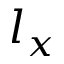<formula> <loc_0><loc_0><loc_500><loc_500>l _ { x }</formula> 